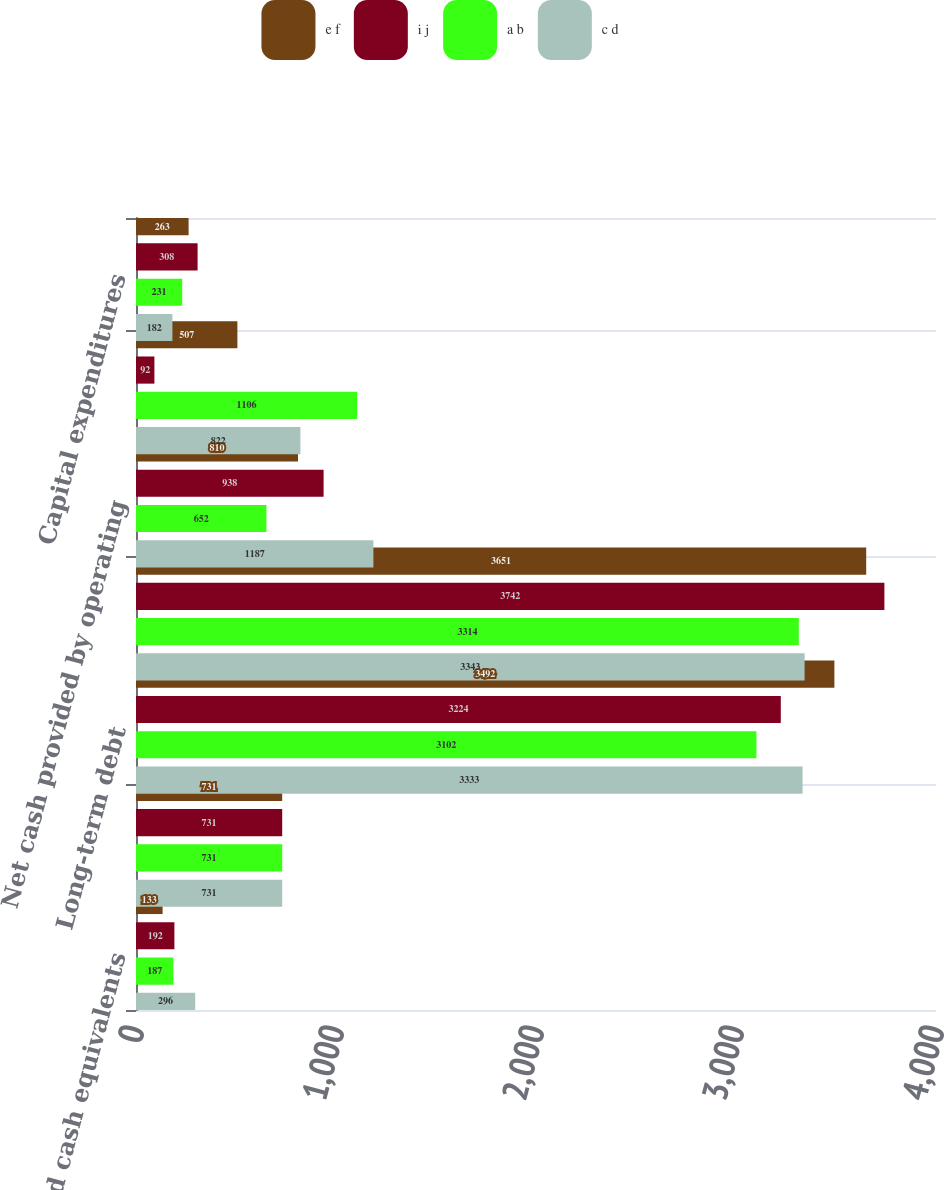<chart> <loc_0><loc_0><loc_500><loc_500><stacked_bar_chart><ecel><fcel>Cash and cash equivalents<fcel>Total assets<fcel>Long-term debt<fcel>Total debt<fcel>Net cash provided by operating<fcel>Net cash (used in) provided by<fcel>Capital expenditures<nl><fcel>e f<fcel>133<fcel>731<fcel>3492<fcel>3651<fcel>810<fcel>507<fcel>263<nl><fcel>i j<fcel>192<fcel>731<fcel>3224<fcel>3742<fcel>938<fcel>92<fcel>308<nl><fcel>a b<fcel>187<fcel>731<fcel>3102<fcel>3314<fcel>652<fcel>1106<fcel>231<nl><fcel>c d<fcel>296<fcel>731<fcel>3333<fcel>3343<fcel>1187<fcel>822<fcel>182<nl></chart> 